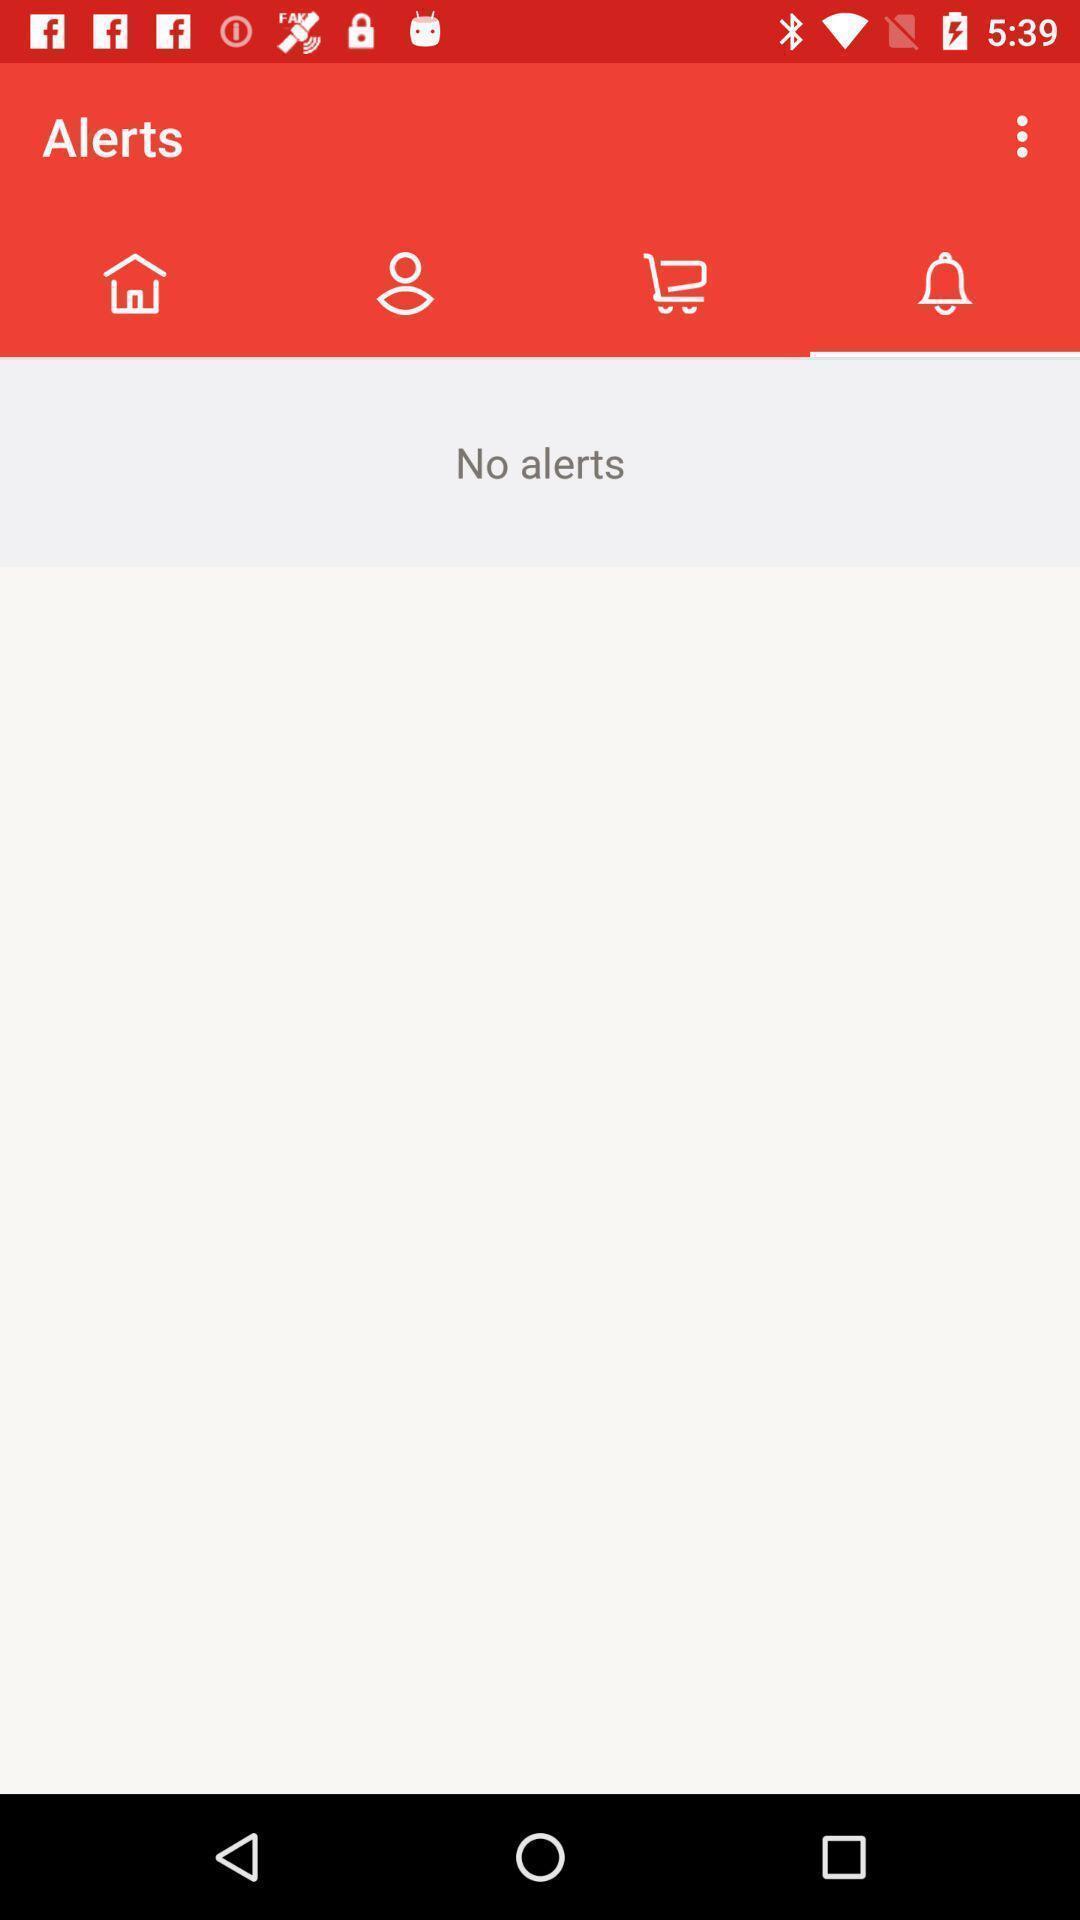Summarize the information in this screenshot. Screen displaying the blank page in alert tab. 